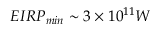<formula> <loc_0><loc_0><loc_500><loc_500>E I R P _ { \min } \sim 3 \times 1 0 ^ { 1 1 } W</formula> 